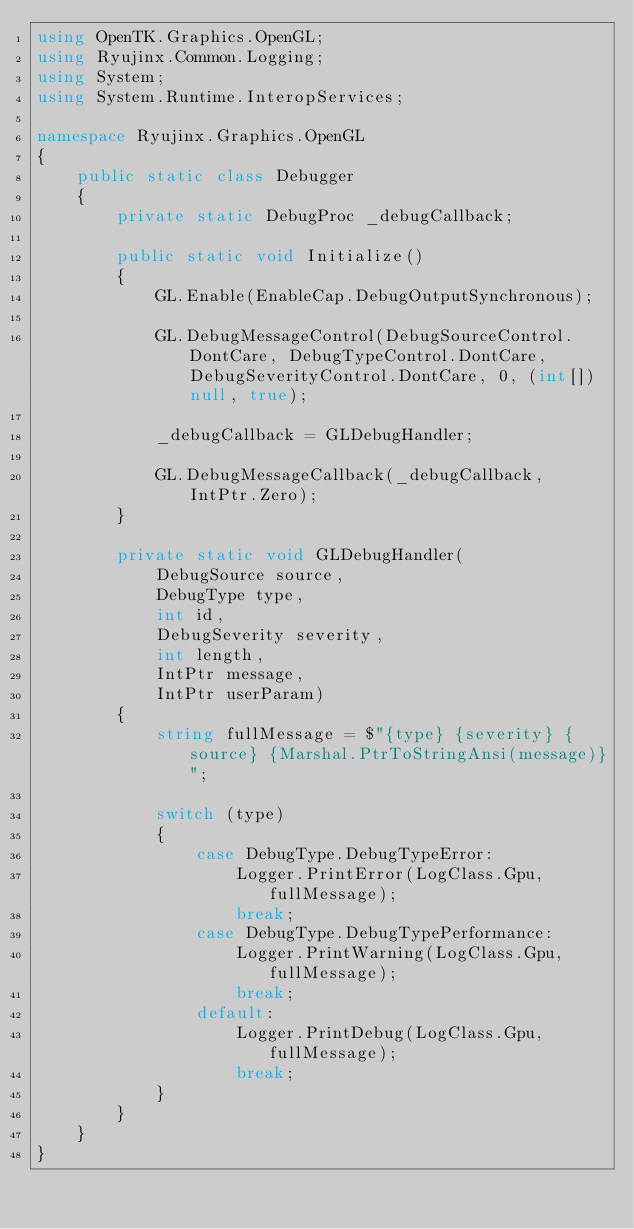<code> <loc_0><loc_0><loc_500><loc_500><_C#_>using OpenTK.Graphics.OpenGL;
using Ryujinx.Common.Logging;
using System;
using System.Runtime.InteropServices;

namespace Ryujinx.Graphics.OpenGL
{
    public static class Debugger
    {
        private static DebugProc _debugCallback;

        public static void Initialize()
        {
            GL.Enable(EnableCap.DebugOutputSynchronous);

            GL.DebugMessageControl(DebugSourceControl.DontCare, DebugTypeControl.DontCare, DebugSeverityControl.DontCare, 0, (int[])null, true);

            _debugCallback = GLDebugHandler;

            GL.DebugMessageCallback(_debugCallback, IntPtr.Zero);
        }

        private static void GLDebugHandler(
            DebugSource source,
            DebugType type,
            int id,
            DebugSeverity severity,
            int length,
            IntPtr message,
            IntPtr userParam)
        {
            string fullMessage = $"{type} {severity} {source} {Marshal.PtrToStringAnsi(message)}";

            switch (type)
            {
                case DebugType.DebugTypeError:
                    Logger.PrintError(LogClass.Gpu, fullMessage);
                    break;
                case DebugType.DebugTypePerformance:
                    Logger.PrintWarning(LogClass.Gpu, fullMessage);
                    break;
                default:
                    Logger.PrintDebug(LogClass.Gpu, fullMessage);
                    break;
            }
        }
    }
}
</code> 